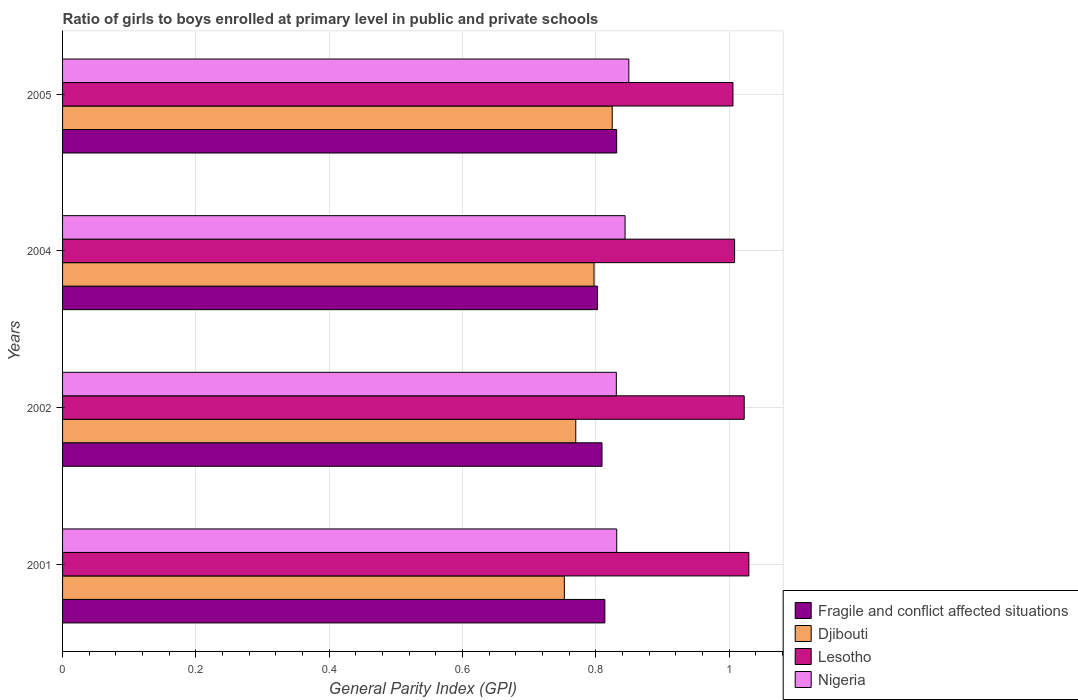What is the label of the 4th group of bars from the top?
Ensure brevity in your answer.  2001. What is the general parity index in Djibouti in 2001?
Provide a short and direct response. 0.75. Across all years, what is the maximum general parity index in Nigeria?
Make the answer very short. 0.85. Across all years, what is the minimum general parity index in Nigeria?
Make the answer very short. 0.83. In which year was the general parity index in Nigeria minimum?
Your answer should be compact. 2002. What is the total general parity index in Fragile and conflict affected situations in the graph?
Your answer should be compact. 3.26. What is the difference between the general parity index in Nigeria in 2002 and that in 2005?
Your response must be concise. -0.02. What is the difference between the general parity index in Fragile and conflict affected situations in 2005 and the general parity index in Nigeria in 2002?
Keep it short and to the point. 0. What is the average general parity index in Nigeria per year?
Your answer should be compact. 0.84. In the year 2001, what is the difference between the general parity index in Lesotho and general parity index in Fragile and conflict affected situations?
Ensure brevity in your answer.  0.22. In how many years, is the general parity index in Nigeria greater than 1.04 ?
Ensure brevity in your answer.  0. What is the ratio of the general parity index in Djibouti in 2001 to that in 2002?
Ensure brevity in your answer.  0.98. Is the general parity index in Lesotho in 2001 less than that in 2004?
Give a very brief answer. No. What is the difference between the highest and the second highest general parity index in Lesotho?
Your response must be concise. 0.01. What is the difference between the highest and the lowest general parity index in Lesotho?
Make the answer very short. 0.02. Is it the case that in every year, the sum of the general parity index in Lesotho and general parity index in Nigeria is greater than the sum of general parity index in Fragile and conflict affected situations and general parity index in Djibouti?
Provide a succinct answer. Yes. What does the 4th bar from the top in 2004 represents?
Make the answer very short. Fragile and conflict affected situations. What does the 3rd bar from the bottom in 2004 represents?
Give a very brief answer. Lesotho. How many bars are there?
Provide a short and direct response. 16. What is the difference between two consecutive major ticks on the X-axis?
Your answer should be very brief. 0.2. Where does the legend appear in the graph?
Your answer should be compact. Bottom right. What is the title of the graph?
Ensure brevity in your answer.  Ratio of girls to boys enrolled at primary level in public and private schools. What is the label or title of the X-axis?
Your answer should be very brief. General Parity Index (GPI). What is the General Parity Index (GPI) of Fragile and conflict affected situations in 2001?
Give a very brief answer. 0.81. What is the General Parity Index (GPI) in Djibouti in 2001?
Ensure brevity in your answer.  0.75. What is the General Parity Index (GPI) in Lesotho in 2001?
Make the answer very short. 1.03. What is the General Parity Index (GPI) of Nigeria in 2001?
Your answer should be very brief. 0.83. What is the General Parity Index (GPI) of Fragile and conflict affected situations in 2002?
Your response must be concise. 0.81. What is the General Parity Index (GPI) in Djibouti in 2002?
Provide a short and direct response. 0.77. What is the General Parity Index (GPI) of Lesotho in 2002?
Provide a short and direct response. 1.02. What is the General Parity Index (GPI) in Nigeria in 2002?
Make the answer very short. 0.83. What is the General Parity Index (GPI) of Fragile and conflict affected situations in 2004?
Offer a terse response. 0.8. What is the General Parity Index (GPI) of Djibouti in 2004?
Your response must be concise. 0.8. What is the General Parity Index (GPI) of Lesotho in 2004?
Offer a terse response. 1.01. What is the General Parity Index (GPI) in Nigeria in 2004?
Provide a short and direct response. 0.84. What is the General Parity Index (GPI) of Fragile and conflict affected situations in 2005?
Make the answer very short. 0.83. What is the General Parity Index (GPI) in Djibouti in 2005?
Offer a very short reply. 0.82. What is the General Parity Index (GPI) of Lesotho in 2005?
Your answer should be compact. 1.01. What is the General Parity Index (GPI) of Nigeria in 2005?
Provide a succinct answer. 0.85. Across all years, what is the maximum General Parity Index (GPI) of Fragile and conflict affected situations?
Make the answer very short. 0.83. Across all years, what is the maximum General Parity Index (GPI) of Djibouti?
Offer a terse response. 0.82. Across all years, what is the maximum General Parity Index (GPI) of Lesotho?
Offer a terse response. 1.03. Across all years, what is the maximum General Parity Index (GPI) of Nigeria?
Your response must be concise. 0.85. Across all years, what is the minimum General Parity Index (GPI) in Fragile and conflict affected situations?
Ensure brevity in your answer.  0.8. Across all years, what is the minimum General Parity Index (GPI) of Djibouti?
Your response must be concise. 0.75. Across all years, what is the minimum General Parity Index (GPI) in Lesotho?
Provide a short and direct response. 1.01. Across all years, what is the minimum General Parity Index (GPI) in Nigeria?
Offer a very short reply. 0.83. What is the total General Parity Index (GPI) of Fragile and conflict affected situations in the graph?
Offer a very short reply. 3.26. What is the total General Parity Index (GPI) of Djibouti in the graph?
Make the answer very short. 3.14. What is the total General Parity Index (GPI) of Lesotho in the graph?
Keep it short and to the point. 4.07. What is the total General Parity Index (GPI) in Nigeria in the graph?
Ensure brevity in your answer.  3.36. What is the difference between the General Parity Index (GPI) of Fragile and conflict affected situations in 2001 and that in 2002?
Provide a short and direct response. 0. What is the difference between the General Parity Index (GPI) of Djibouti in 2001 and that in 2002?
Provide a succinct answer. -0.02. What is the difference between the General Parity Index (GPI) of Lesotho in 2001 and that in 2002?
Make the answer very short. 0.01. What is the difference between the General Parity Index (GPI) of Nigeria in 2001 and that in 2002?
Make the answer very short. 0. What is the difference between the General Parity Index (GPI) in Fragile and conflict affected situations in 2001 and that in 2004?
Your answer should be compact. 0.01. What is the difference between the General Parity Index (GPI) in Djibouti in 2001 and that in 2004?
Your answer should be compact. -0.04. What is the difference between the General Parity Index (GPI) of Lesotho in 2001 and that in 2004?
Give a very brief answer. 0.02. What is the difference between the General Parity Index (GPI) in Nigeria in 2001 and that in 2004?
Make the answer very short. -0.01. What is the difference between the General Parity Index (GPI) of Fragile and conflict affected situations in 2001 and that in 2005?
Offer a terse response. -0.02. What is the difference between the General Parity Index (GPI) of Djibouti in 2001 and that in 2005?
Offer a very short reply. -0.07. What is the difference between the General Parity Index (GPI) in Lesotho in 2001 and that in 2005?
Ensure brevity in your answer.  0.02. What is the difference between the General Parity Index (GPI) of Nigeria in 2001 and that in 2005?
Provide a short and direct response. -0.02. What is the difference between the General Parity Index (GPI) in Fragile and conflict affected situations in 2002 and that in 2004?
Offer a terse response. 0.01. What is the difference between the General Parity Index (GPI) in Djibouti in 2002 and that in 2004?
Keep it short and to the point. -0.03. What is the difference between the General Parity Index (GPI) of Lesotho in 2002 and that in 2004?
Provide a short and direct response. 0.01. What is the difference between the General Parity Index (GPI) in Nigeria in 2002 and that in 2004?
Your response must be concise. -0.01. What is the difference between the General Parity Index (GPI) in Fragile and conflict affected situations in 2002 and that in 2005?
Keep it short and to the point. -0.02. What is the difference between the General Parity Index (GPI) in Djibouti in 2002 and that in 2005?
Keep it short and to the point. -0.05. What is the difference between the General Parity Index (GPI) in Lesotho in 2002 and that in 2005?
Your answer should be very brief. 0.02. What is the difference between the General Parity Index (GPI) in Nigeria in 2002 and that in 2005?
Your answer should be very brief. -0.02. What is the difference between the General Parity Index (GPI) in Fragile and conflict affected situations in 2004 and that in 2005?
Keep it short and to the point. -0.03. What is the difference between the General Parity Index (GPI) in Djibouti in 2004 and that in 2005?
Your answer should be compact. -0.03. What is the difference between the General Parity Index (GPI) in Lesotho in 2004 and that in 2005?
Your answer should be very brief. 0. What is the difference between the General Parity Index (GPI) of Nigeria in 2004 and that in 2005?
Offer a terse response. -0.01. What is the difference between the General Parity Index (GPI) of Fragile and conflict affected situations in 2001 and the General Parity Index (GPI) of Djibouti in 2002?
Your response must be concise. 0.04. What is the difference between the General Parity Index (GPI) of Fragile and conflict affected situations in 2001 and the General Parity Index (GPI) of Lesotho in 2002?
Provide a succinct answer. -0.21. What is the difference between the General Parity Index (GPI) in Fragile and conflict affected situations in 2001 and the General Parity Index (GPI) in Nigeria in 2002?
Provide a short and direct response. -0.02. What is the difference between the General Parity Index (GPI) in Djibouti in 2001 and the General Parity Index (GPI) in Lesotho in 2002?
Your answer should be compact. -0.27. What is the difference between the General Parity Index (GPI) of Djibouti in 2001 and the General Parity Index (GPI) of Nigeria in 2002?
Your answer should be compact. -0.08. What is the difference between the General Parity Index (GPI) of Lesotho in 2001 and the General Parity Index (GPI) of Nigeria in 2002?
Make the answer very short. 0.2. What is the difference between the General Parity Index (GPI) of Fragile and conflict affected situations in 2001 and the General Parity Index (GPI) of Djibouti in 2004?
Offer a very short reply. 0.02. What is the difference between the General Parity Index (GPI) in Fragile and conflict affected situations in 2001 and the General Parity Index (GPI) in Lesotho in 2004?
Provide a short and direct response. -0.19. What is the difference between the General Parity Index (GPI) in Fragile and conflict affected situations in 2001 and the General Parity Index (GPI) in Nigeria in 2004?
Offer a terse response. -0.03. What is the difference between the General Parity Index (GPI) of Djibouti in 2001 and the General Parity Index (GPI) of Lesotho in 2004?
Offer a terse response. -0.26. What is the difference between the General Parity Index (GPI) of Djibouti in 2001 and the General Parity Index (GPI) of Nigeria in 2004?
Provide a short and direct response. -0.09. What is the difference between the General Parity Index (GPI) in Lesotho in 2001 and the General Parity Index (GPI) in Nigeria in 2004?
Your answer should be compact. 0.19. What is the difference between the General Parity Index (GPI) of Fragile and conflict affected situations in 2001 and the General Parity Index (GPI) of Djibouti in 2005?
Offer a very short reply. -0.01. What is the difference between the General Parity Index (GPI) of Fragile and conflict affected situations in 2001 and the General Parity Index (GPI) of Lesotho in 2005?
Keep it short and to the point. -0.19. What is the difference between the General Parity Index (GPI) of Fragile and conflict affected situations in 2001 and the General Parity Index (GPI) of Nigeria in 2005?
Your answer should be compact. -0.04. What is the difference between the General Parity Index (GPI) in Djibouti in 2001 and the General Parity Index (GPI) in Lesotho in 2005?
Offer a terse response. -0.25. What is the difference between the General Parity Index (GPI) in Djibouti in 2001 and the General Parity Index (GPI) in Nigeria in 2005?
Ensure brevity in your answer.  -0.1. What is the difference between the General Parity Index (GPI) of Lesotho in 2001 and the General Parity Index (GPI) of Nigeria in 2005?
Your answer should be compact. 0.18. What is the difference between the General Parity Index (GPI) of Fragile and conflict affected situations in 2002 and the General Parity Index (GPI) of Djibouti in 2004?
Provide a short and direct response. 0.01. What is the difference between the General Parity Index (GPI) of Fragile and conflict affected situations in 2002 and the General Parity Index (GPI) of Lesotho in 2004?
Your response must be concise. -0.2. What is the difference between the General Parity Index (GPI) of Fragile and conflict affected situations in 2002 and the General Parity Index (GPI) of Nigeria in 2004?
Provide a short and direct response. -0.03. What is the difference between the General Parity Index (GPI) of Djibouti in 2002 and the General Parity Index (GPI) of Lesotho in 2004?
Make the answer very short. -0.24. What is the difference between the General Parity Index (GPI) of Djibouti in 2002 and the General Parity Index (GPI) of Nigeria in 2004?
Make the answer very short. -0.07. What is the difference between the General Parity Index (GPI) of Lesotho in 2002 and the General Parity Index (GPI) of Nigeria in 2004?
Keep it short and to the point. 0.18. What is the difference between the General Parity Index (GPI) of Fragile and conflict affected situations in 2002 and the General Parity Index (GPI) of Djibouti in 2005?
Give a very brief answer. -0.02. What is the difference between the General Parity Index (GPI) of Fragile and conflict affected situations in 2002 and the General Parity Index (GPI) of Lesotho in 2005?
Make the answer very short. -0.2. What is the difference between the General Parity Index (GPI) in Fragile and conflict affected situations in 2002 and the General Parity Index (GPI) in Nigeria in 2005?
Offer a terse response. -0.04. What is the difference between the General Parity Index (GPI) of Djibouti in 2002 and the General Parity Index (GPI) of Lesotho in 2005?
Ensure brevity in your answer.  -0.24. What is the difference between the General Parity Index (GPI) in Djibouti in 2002 and the General Parity Index (GPI) in Nigeria in 2005?
Make the answer very short. -0.08. What is the difference between the General Parity Index (GPI) of Lesotho in 2002 and the General Parity Index (GPI) of Nigeria in 2005?
Make the answer very short. 0.17. What is the difference between the General Parity Index (GPI) in Fragile and conflict affected situations in 2004 and the General Parity Index (GPI) in Djibouti in 2005?
Ensure brevity in your answer.  -0.02. What is the difference between the General Parity Index (GPI) in Fragile and conflict affected situations in 2004 and the General Parity Index (GPI) in Lesotho in 2005?
Your answer should be very brief. -0.2. What is the difference between the General Parity Index (GPI) in Fragile and conflict affected situations in 2004 and the General Parity Index (GPI) in Nigeria in 2005?
Provide a short and direct response. -0.05. What is the difference between the General Parity Index (GPI) of Djibouti in 2004 and the General Parity Index (GPI) of Lesotho in 2005?
Your answer should be very brief. -0.21. What is the difference between the General Parity Index (GPI) in Djibouti in 2004 and the General Parity Index (GPI) in Nigeria in 2005?
Keep it short and to the point. -0.05. What is the difference between the General Parity Index (GPI) in Lesotho in 2004 and the General Parity Index (GPI) in Nigeria in 2005?
Provide a short and direct response. 0.16. What is the average General Parity Index (GPI) in Fragile and conflict affected situations per year?
Your answer should be compact. 0.81. What is the average General Parity Index (GPI) in Djibouti per year?
Give a very brief answer. 0.79. What is the average General Parity Index (GPI) in Lesotho per year?
Offer a very short reply. 1.02. What is the average General Parity Index (GPI) of Nigeria per year?
Provide a short and direct response. 0.84. In the year 2001, what is the difference between the General Parity Index (GPI) of Fragile and conflict affected situations and General Parity Index (GPI) of Djibouti?
Keep it short and to the point. 0.06. In the year 2001, what is the difference between the General Parity Index (GPI) of Fragile and conflict affected situations and General Parity Index (GPI) of Lesotho?
Your answer should be compact. -0.22. In the year 2001, what is the difference between the General Parity Index (GPI) of Fragile and conflict affected situations and General Parity Index (GPI) of Nigeria?
Provide a succinct answer. -0.02. In the year 2001, what is the difference between the General Parity Index (GPI) in Djibouti and General Parity Index (GPI) in Lesotho?
Provide a succinct answer. -0.28. In the year 2001, what is the difference between the General Parity Index (GPI) in Djibouti and General Parity Index (GPI) in Nigeria?
Your answer should be very brief. -0.08. In the year 2001, what is the difference between the General Parity Index (GPI) of Lesotho and General Parity Index (GPI) of Nigeria?
Your answer should be compact. 0.2. In the year 2002, what is the difference between the General Parity Index (GPI) in Fragile and conflict affected situations and General Parity Index (GPI) in Djibouti?
Your answer should be compact. 0.04. In the year 2002, what is the difference between the General Parity Index (GPI) of Fragile and conflict affected situations and General Parity Index (GPI) of Lesotho?
Your response must be concise. -0.21. In the year 2002, what is the difference between the General Parity Index (GPI) in Fragile and conflict affected situations and General Parity Index (GPI) in Nigeria?
Provide a succinct answer. -0.02. In the year 2002, what is the difference between the General Parity Index (GPI) of Djibouti and General Parity Index (GPI) of Lesotho?
Make the answer very short. -0.25. In the year 2002, what is the difference between the General Parity Index (GPI) in Djibouti and General Parity Index (GPI) in Nigeria?
Provide a short and direct response. -0.06. In the year 2002, what is the difference between the General Parity Index (GPI) of Lesotho and General Parity Index (GPI) of Nigeria?
Offer a terse response. 0.19. In the year 2004, what is the difference between the General Parity Index (GPI) of Fragile and conflict affected situations and General Parity Index (GPI) of Djibouti?
Provide a short and direct response. 0.01. In the year 2004, what is the difference between the General Parity Index (GPI) of Fragile and conflict affected situations and General Parity Index (GPI) of Lesotho?
Your answer should be very brief. -0.21. In the year 2004, what is the difference between the General Parity Index (GPI) of Fragile and conflict affected situations and General Parity Index (GPI) of Nigeria?
Make the answer very short. -0.04. In the year 2004, what is the difference between the General Parity Index (GPI) of Djibouti and General Parity Index (GPI) of Lesotho?
Ensure brevity in your answer.  -0.21. In the year 2004, what is the difference between the General Parity Index (GPI) of Djibouti and General Parity Index (GPI) of Nigeria?
Your answer should be compact. -0.05. In the year 2004, what is the difference between the General Parity Index (GPI) of Lesotho and General Parity Index (GPI) of Nigeria?
Ensure brevity in your answer.  0.16. In the year 2005, what is the difference between the General Parity Index (GPI) in Fragile and conflict affected situations and General Parity Index (GPI) in Djibouti?
Make the answer very short. 0.01. In the year 2005, what is the difference between the General Parity Index (GPI) of Fragile and conflict affected situations and General Parity Index (GPI) of Lesotho?
Offer a very short reply. -0.17. In the year 2005, what is the difference between the General Parity Index (GPI) in Fragile and conflict affected situations and General Parity Index (GPI) in Nigeria?
Offer a very short reply. -0.02. In the year 2005, what is the difference between the General Parity Index (GPI) of Djibouti and General Parity Index (GPI) of Lesotho?
Make the answer very short. -0.18. In the year 2005, what is the difference between the General Parity Index (GPI) of Djibouti and General Parity Index (GPI) of Nigeria?
Make the answer very short. -0.02. In the year 2005, what is the difference between the General Parity Index (GPI) of Lesotho and General Parity Index (GPI) of Nigeria?
Provide a succinct answer. 0.16. What is the ratio of the General Parity Index (GPI) in Djibouti in 2001 to that in 2002?
Provide a succinct answer. 0.98. What is the ratio of the General Parity Index (GPI) of Lesotho in 2001 to that in 2002?
Make the answer very short. 1.01. What is the ratio of the General Parity Index (GPI) in Fragile and conflict affected situations in 2001 to that in 2004?
Offer a terse response. 1.01. What is the ratio of the General Parity Index (GPI) in Djibouti in 2001 to that in 2004?
Make the answer very short. 0.94. What is the ratio of the General Parity Index (GPI) in Lesotho in 2001 to that in 2004?
Offer a very short reply. 1.02. What is the ratio of the General Parity Index (GPI) of Nigeria in 2001 to that in 2004?
Provide a succinct answer. 0.99. What is the ratio of the General Parity Index (GPI) of Fragile and conflict affected situations in 2001 to that in 2005?
Your answer should be compact. 0.98. What is the ratio of the General Parity Index (GPI) in Djibouti in 2001 to that in 2005?
Make the answer very short. 0.91. What is the ratio of the General Parity Index (GPI) of Lesotho in 2001 to that in 2005?
Ensure brevity in your answer.  1.02. What is the ratio of the General Parity Index (GPI) in Nigeria in 2001 to that in 2005?
Your response must be concise. 0.98. What is the ratio of the General Parity Index (GPI) of Fragile and conflict affected situations in 2002 to that in 2004?
Provide a succinct answer. 1.01. What is the ratio of the General Parity Index (GPI) of Djibouti in 2002 to that in 2004?
Offer a terse response. 0.97. What is the ratio of the General Parity Index (GPI) of Lesotho in 2002 to that in 2004?
Provide a succinct answer. 1.01. What is the ratio of the General Parity Index (GPI) in Nigeria in 2002 to that in 2004?
Ensure brevity in your answer.  0.98. What is the ratio of the General Parity Index (GPI) of Fragile and conflict affected situations in 2002 to that in 2005?
Provide a succinct answer. 0.97. What is the ratio of the General Parity Index (GPI) of Djibouti in 2002 to that in 2005?
Offer a very short reply. 0.93. What is the ratio of the General Parity Index (GPI) in Lesotho in 2002 to that in 2005?
Provide a short and direct response. 1.02. What is the ratio of the General Parity Index (GPI) in Nigeria in 2002 to that in 2005?
Ensure brevity in your answer.  0.98. What is the ratio of the General Parity Index (GPI) in Fragile and conflict affected situations in 2004 to that in 2005?
Make the answer very short. 0.97. What is the ratio of the General Parity Index (GPI) in Djibouti in 2004 to that in 2005?
Your answer should be compact. 0.97. What is the ratio of the General Parity Index (GPI) of Lesotho in 2004 to that in 2005?
Offer a terse response. 1. What is the ratio of the General Parity Index (GPI) of Nigeria in 2004 to that in 2005?
Keep it short and to the point. 0.99. What is the difference between the highest and the second highest General Parity Index (GPI) in Fragile and conflict affected situations?
Offer a terse response. 0.02. What is the difference between the highest and the second highest General Parity Index (GPI) in Djibouti?
Provide a succinct answer. 0.03. What is the difference between the highest and the second highest General Parity Index (GPI) of Lesotho?
Your answer should be very brief. 0.01. What is the difference between the highest and the second highest General Parity Index (GPI) of Nigeria?
Give a very brief answer. 0.01. What is the difference between the highest and the lowest General Parity Index (GPI) of Fragile and conflict affected situations?
Give a very brief answer. 0.03. What is the difference between the highest and the lowest General Parity Index (GPI) of Djibouti?
Provide a short and direct response. 0.07. What is the difference between the highest and the lowest General Parity Index (GPI) in Lesotho?
Offer a very short reply. 0.02. What is the difference between the highest and the lowest General Parity Index (GPI) of Nigeria?
Give a very brief answer. 0.02. 